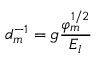Convert formula to latex. <formula><loc_0><loc_0><loc_500><loc_500>d _ { m } ^ { - 1 } = g \frac { \varphi _ { m } ^ { 1 / 2 } } { E _ { l } }</formula> 